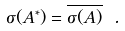<formula> <loc_0><loc_0><loc_500><loc_500>\sigma ( A ^ { * } ) = \overline { \sigma ( A ) } \ .</formula> 